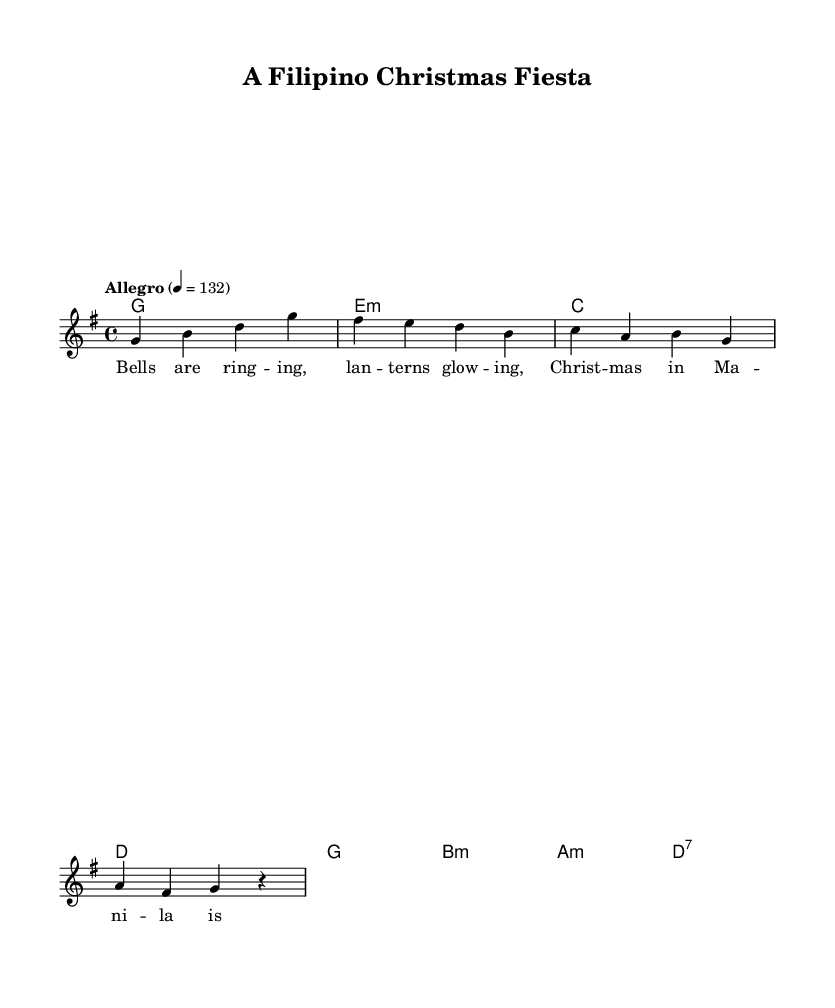What is the key signature of this music? The key signature is G major, which has one sharp (F sharp). This is indicated at the beginning of the score with the G major key signature.
Answer: G major What is the time signature of this music? The time signature is 4/4, as noted at the beginning of the score. This means there are four beats in each measure, with a quarter note receiving one beat.
Answer: 4/4 What is the tempo marking of this music? The tempo marking is "Allegro," which suggests a fast and lively speed for the performance. The specific tempo is indicated as 132 beats per minute.
Answer: Allegro How many measures are in the melody? The melody consists of four measures, which can be counted by looking at the division of the staff and the notes within it. Each group of notes is separated by vertical lines indicating measures.
Answer: Four measures What is the first chord in the harmonies? The first chord in the harmonies is G major. This is found at the start of the chord progression listed above the staff, where the G major chord is specified.
Answer: G major Which festive theme does the lyrics of this music suggest? The lyrics mention "Bells are ringing" and "Christmas," indicating a celebration associated with the holiday season, specifically Christmas festivities in Manila. This reflects a joyful and festive spirit.
Answer: Christmas What is the structure of the musical number? The structure consists of alternating melodies and harmonies, with lyrics set to the melody. This organization is evident as the melodies, harmonies, and lyrics are distinct yet interwoven in the score layout.
Answer: Verse 